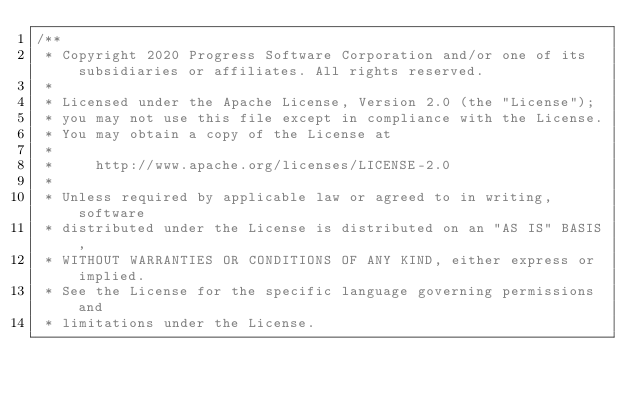<code> <loc_0><loc_0><loc_500><loc_500><_CSS_>/** 
 * Copyright 2020 Progress Software Corporation and/or one of its subsidiaries or affiliates. All rights reserved.                                                                                      
 *                                                                                                                                                                                                      
 * Licensed under the Apache License, Version 2.0 (the "License");                                                                                                                                      
 * you may not use this file except in compliance with the License.                                                                                                                                     
 * You may obtain a copy of the License at                                                                                                                                                              
 *                                                                                                                                                                                                      
 *     http://www.apache.org/licenses/LICENSE-2.0                                                                                                                                                       
 *                                                                                                                                                                                                      
 * Unless required by applicable law or agreed to in writing, software                                                                                                                                  
 * distributed under the License is distributed on an "AS IS" BASIS,                                                                                                                                    
 * WITHOUT WARRANTIES OR CONDITIONS OF ANY KIND, either express or implied.                                                                                                                             
 * See the License for the specific language governing permissions and                                                                                                                                  
 * limitations under the License.                                                                                                                                                                       
                                                                                                                                                                                                       
                                                                                                                                                                                                       
                                                                                                                                                                                                       
                                                                                                                                                                                                       
                                                                                                                                                                                                       
                                                                                                                                                                                                       
                                                                                                                                                                                                       
                                                                                                                                                                                                       
</code> 